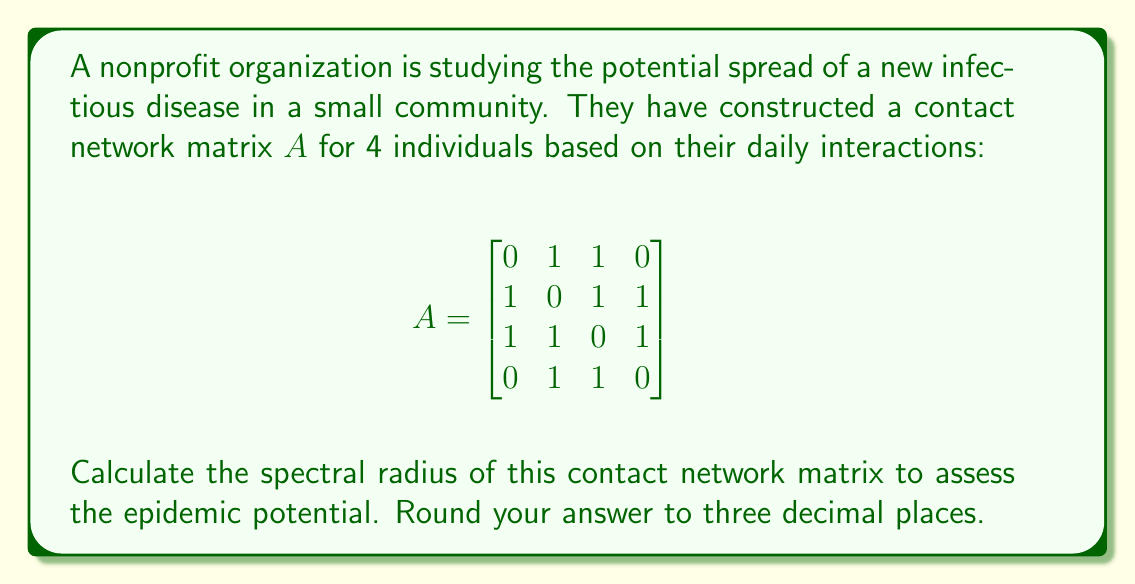What is the answer to this math problem? To calculate the spectral radius of the contact network matrix, we need to follow these steps:

1) First, we need to find the characteristic polynomial of the matrix $A$. The characteristic polynomial is given by $det(A - \lambda I)$, where $I$ is the identity matrix and $\lambda$ is a variable.

2) Expanding the determinant:
   $$det(A - \lambda I) = \begin{vmatrix}
   -\lambda & 1 & 1 & 0 \\
   1 & -\lambda & 1 & 1 \\
   1 & 1 & -\lambda & 1 \\
   0 & 1 & 1 & -\lambda
   \end{vmatrix}$$

3) Calculating this determinant (which can be done using various methods), we get:
   $$\lambda^4 - 6\lambda^2 + 4 = 0$$

4) This is a quadratic equation in $\lambda^2$. Let $u = \lambda^2$, then:
   $$u^2 - 6u + 4 = 0$$

5) Solving this quadratic equation:
   $$u = \frac{6 \pm \sqrt{36 - 16}}{2} = \frac{6 \pm \sqrt{20}}{2} = 3 \pm \sqrt{5}$$

6) Therefore, $\lambda^2 = 3 + \sqrt{5}$ or $\lambda^2 = 3 - \sqrt{5}$

7) The spectral radius is the largest absolute eigenvalue. So we need the positive square root of the larger $\lambda^2$:
   $$\rho(A) = \sqrt{3 + \sqrt{5}}$$

8) Calculating this and rounding to three decimal places:
   $$\rho(A) \approx 2.058$$
Answer: 2.058 